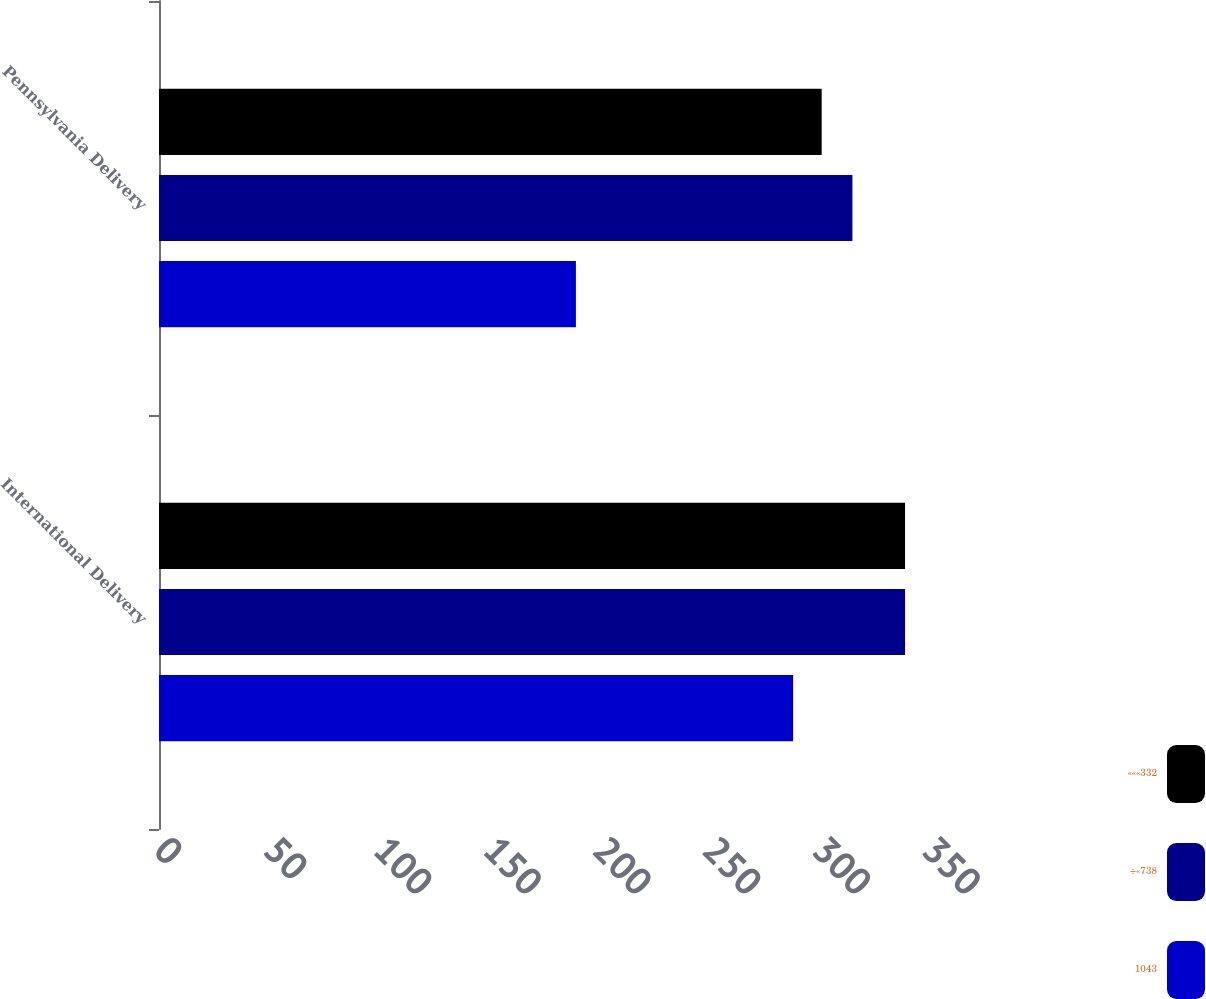Convert chart to OTSL. <chart><loc_0><loc_0><loc_500><loc_500><stacked_bar_chart><ecel><fcel>International Delivery<fcel>Pennsylvania Delivery<nl><fcel>«««332<fcel>340<fcel>302<nl><fcel>÷«738<fcel>340<fcel>316<nl><fcel>1043<fcel>289<fcel>190<nl></chart> 